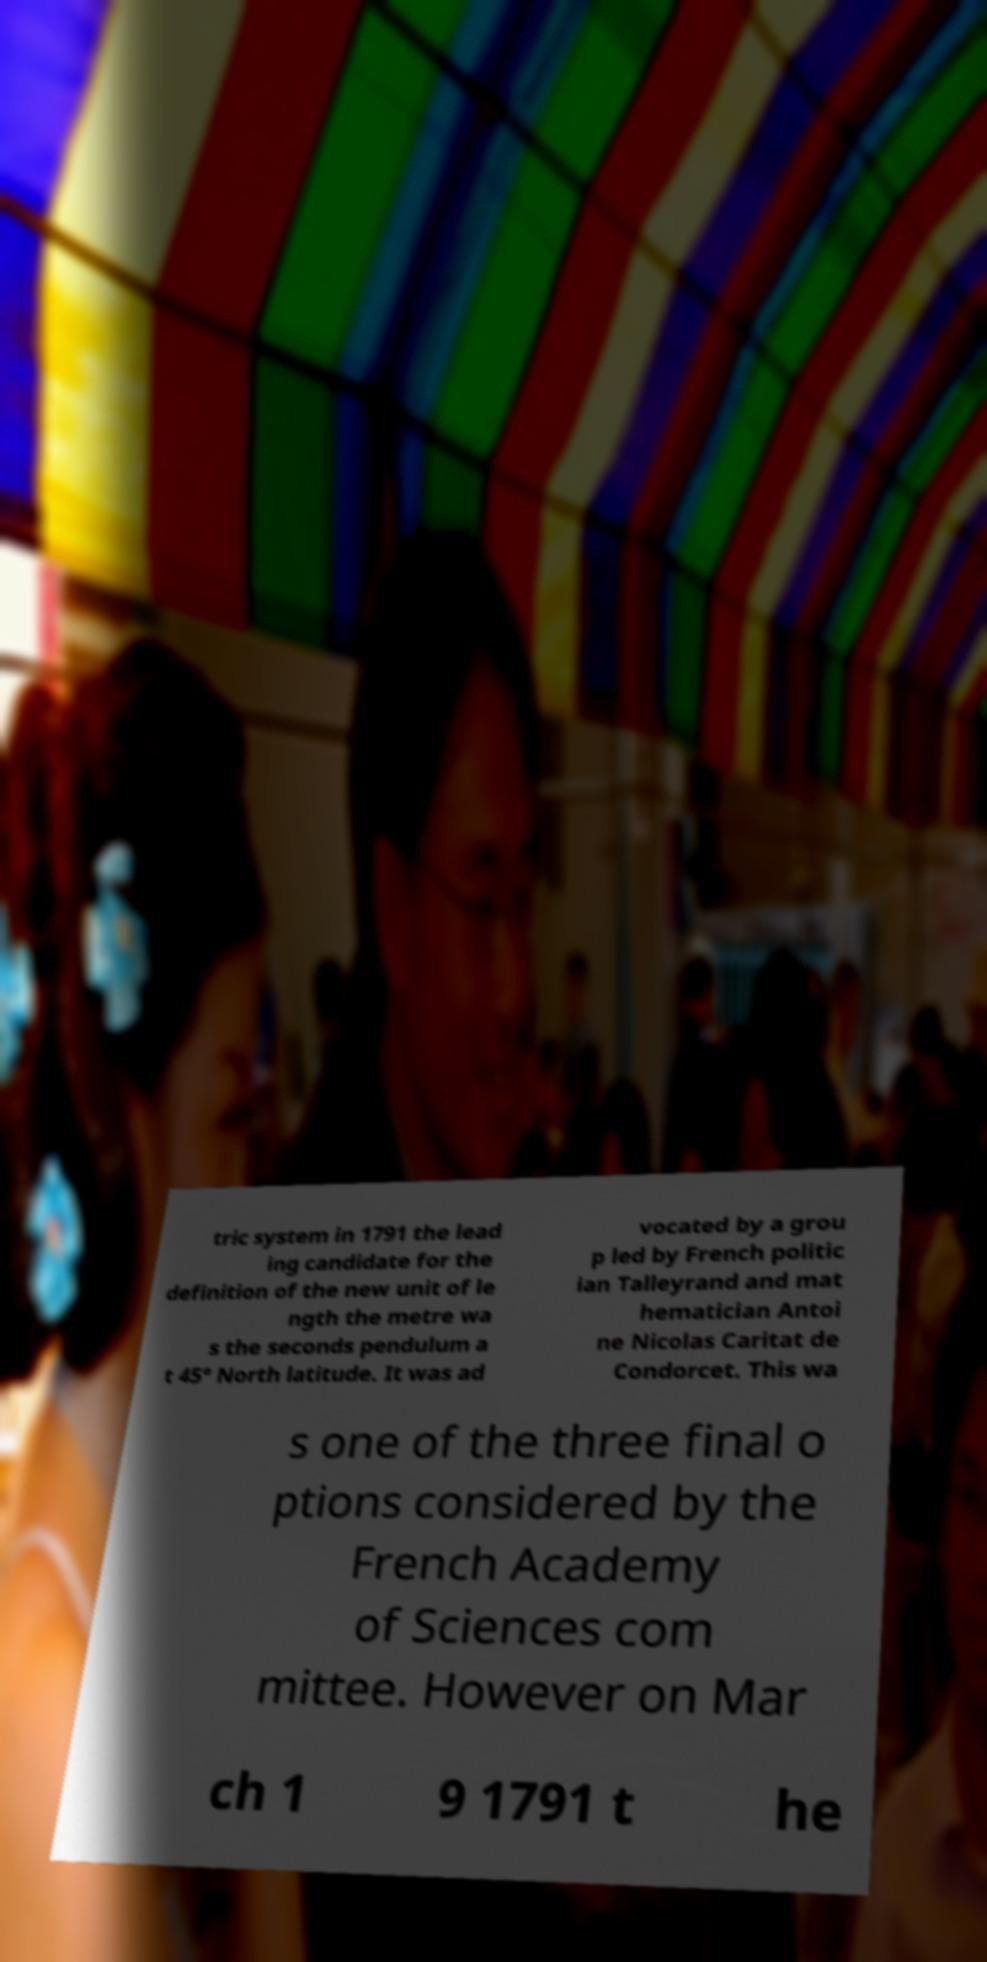Could you extract and type out the text from this image? tric system in 1791 the lead ing candidate for the definition of the new unit of le ngth the metre wa s the seconds pendulum a t 45° North latitude. It was ad vocated by a grou p led by French politic ian Talleyrand and mat hematician Antoi ne Nicolas Caritat de Condorcet. This wa s one of the three final o ptions considered by the French Academy of Sciences com mittee. However on Mar ch 1 9 1791 t he 